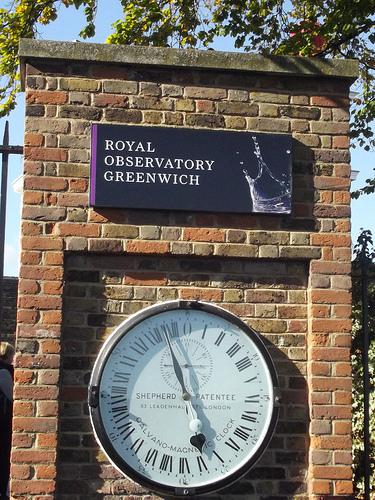Question: what color are the leaves?
Choices:
A. Green.
B. Brown.
C. Red.
D. Orange.
Answer with the letter. Answer: A Question: what color is the clock?
Choices:
A. Silver.
B. Blue.
C. Black and white.
D. Red.
Answer with the letter. Answer: C 